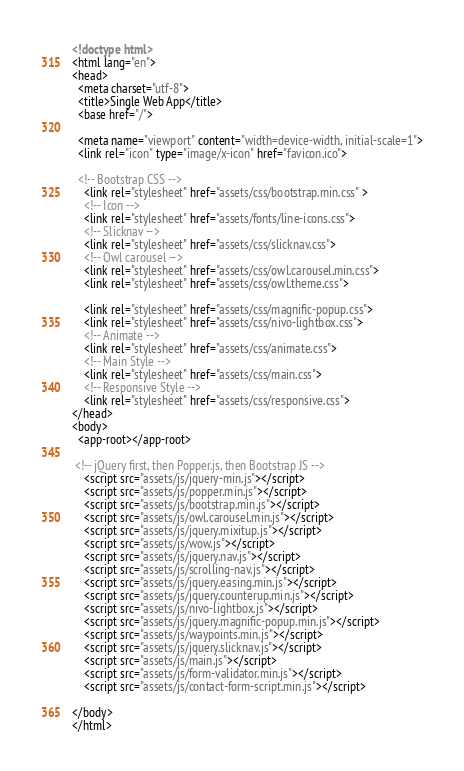<code> <loc_0><loc_0><loc_500><loc_500><_HTML_><!doctype html>
<html lang="en">
<head>
  <meta charset="utf-8">
  <title>Single Web App</title>
  <base href="/">

  <meta name="viewport" content="width=device-width, initial-scale=1">
  <link rel="icon" type="image/x-icon" href="favicon.ico">

  <!-- Bootstrap CSS -->
    <link rel="stylesheet" href="assets/css/bootstrap.min.css" >
    <!-- Icon -->
    <link rel="stylesheet" href="assets/fonts/line-icons.css">
    <!-- Slicknav -->
    <link rel="stylesheet" href="assets/css/slicknav.css">
    <!-- Owl carousel -->
    <link rel="stylesheet" href="assets/css/owl.carousel.min.css">
    <link rel="stylesheet" href="assets/css/owl.theme.css">
    
    <link rel="stylesheet" href="assets/css/magnific-popup.css">
    <link rel="stylesheet" href="assets/css/nivo-lightbox.css">
    <!-- Animate -->
    <link rel="stylesheet" href="assets/css/animate.css">
    <!-- Main Style -->
    <link rel="stylesheet" href="assets/css/main.css">
    <!-- Responsive Style -->
    <link rel="stylesheet" href="assets/css/responsive.css">
</head>
<body>
  <app-root></app-root>

 <!-- jQuery first, then Popper.js, then Bootstrap JS -->
    <script src="assets/js/jquery-min.js"></script>
    <script src="assets/js/popper.min.js"></script>
    <script src="assets/js/bootstrap.min.js"></script>
    <script src="assets/js/owl.carousel.min.js"></script>
    <script src="assets/js/jquery.mixitup.js"></script>
    <script src="assets/js/wow.js"></script>
    <script src="assets/js/jquery.nav.js"></script>
    <script src="assets/js/scrolling-nav.js"></script>
    <script src="assets/js/jquery.easing.min.js"></script>
    <script src="assets/js/jquery.counterup.min.js"></script>  
    <script src="assets/js/nivo-lightbox.js"></script>     
    <script src="assets/js/jquery.magnific-popup.min.js"></script>     
    <script src="assets/js/waypoints.min.js"></script>   
    <script src="assets/js/jquery.slicknav.js"></script>
    <script src="assets/js/main.js"></script>
    <script src="assets/js/form-validator.min.js"></script>
    <script src="assets/js/contact-form-script.min.js"></script>
  
</body>
</html>
</code> 